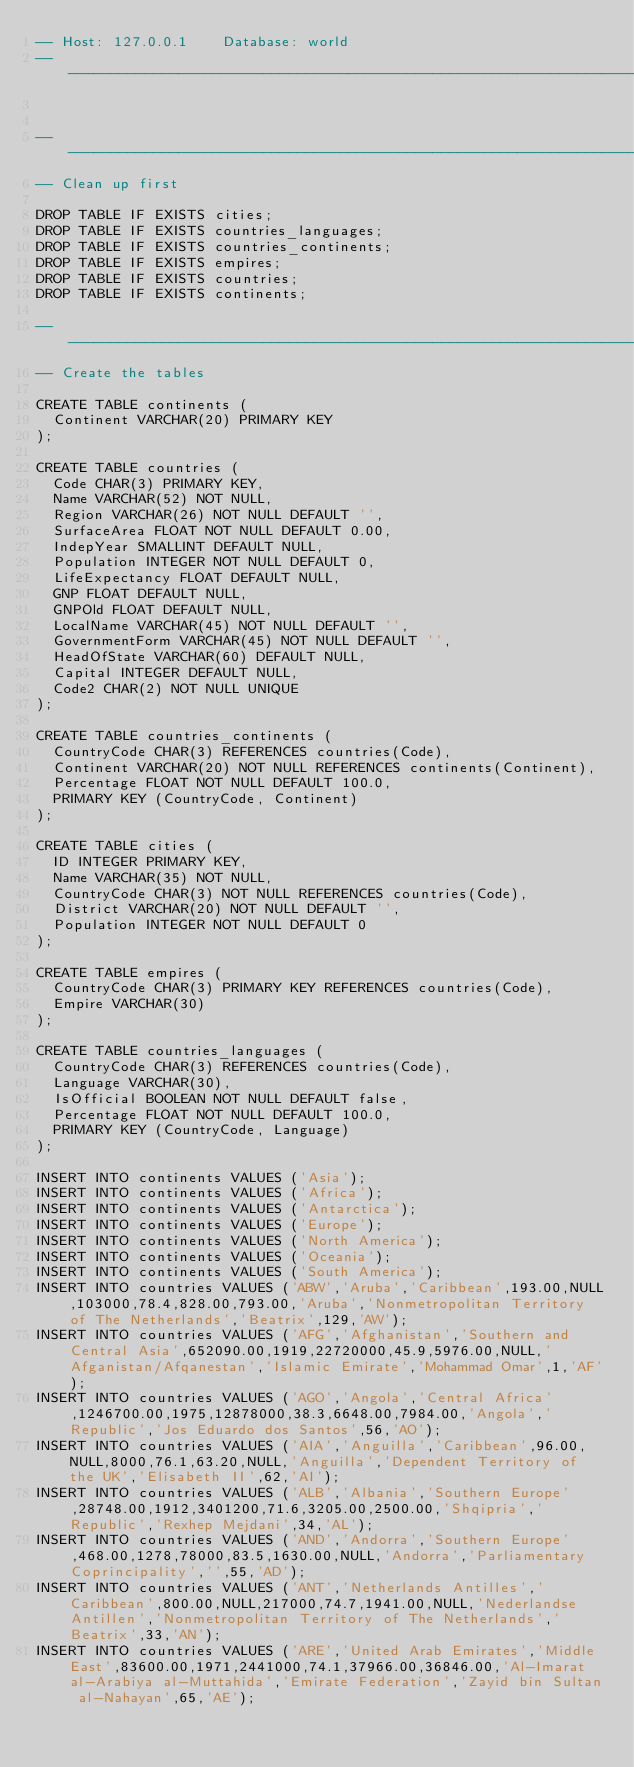<code> <loc_0><loc_0><loc_500><loc_500><_SQL_>-- Host: 127.0.0.1    Database: world
-- ----------------------------------------------------------------------------------------------------------------


-- ----------------------------------------------------------------------------------------------------------------
-- Clean up first

DROP TABLE IF EXISTS cities;
DROP TABLE IF EXISTS countries_languages;
DROP TABLE IF EXISTS countries_continents;
DROP TABLE IF EXISTS empires;
DROP TABLE IF EXISTS countries;
DROP TABLE IF EXISTS continents;

-- ----------------------------------------------------------------------------------------------------------------
-- Create the tables

CREATE TABLE continents (
  Continent VARCHAR(20) PRIMARY KEY
);

CREATE TABLE countries (
  Code CHAR(3) PRIMARY KEY,
  Name VARCHAR(52) NOT NULL,
  Region VARCHAR(26) NOT NULL DEFAULT '',
  SurfaceArea FLOAT NOT NULL DEFAULT 0.00,
  IndepYear SMALLINT DEFAULT NULL,
  Population INTEGER NOT NULL DEFAULT 0,
  LifeExpectancy FLOAT DEFAULT NULL,
  GNP FLOAT DEFAULT NULL,
  GNPOld FLOAT DEFAULT NULL,
  LocalName VARCHAR(45) NOT NULL DEFAULT '',
  GovernmentForm VARCHAR(45) NOT NULL DEFAULT '',
  HeadOfState VARCHAR(60) DEFAULT NULL,
  Capital INTEGER DEFAULT NULL,
  Code2 CHAR(2) NOT NULL UNIQUE
);

CREATE TABLE countries_continents (
  CountryCode CHAR(3) REFERENCES countries(Code),
  Continent VARCHAR(20) NOT NULL REFERENCES continents(Continent),
  Percentage FLOAT NOT NULL DEFAULT 100.0,
  PRIMARY KEY (CountryCode, Continent)
);

CREATE TABLE cities (
  ID INTEGER PRIMARY KEY,
  Name VARCHAR(35) NOT NULL,
  CountryCode CHAR(3) NOT NULL REFERENCES countries(Code),
  District VARCHAR(20) NOT NULL DEFAULT '',
  Population INTEGER NOT NULL DEFAULT 0
);

CREATE TABLE empires (
  CountryCode CHAR(3) PRIMARY KEY REFERENCES countries(Code),
  Empire VARCHAR(30)
);

CREATE TABLE countries_languages (
  CountryCode CHAR(3) REFERENCES countries(Code),
  Language VARCHAR(30),
  IsOfficial BOOLEAN NOT NULL DEFAULT false,
  Percentage FLOAT NOT NULL DEFAULT 100.0,
  PRIMARY KEY (CountryCode, Language)
);

INSERT INTO continents VALUES ('Asia');
INSERT INTO continents VALUES ('Africa');
INSERT INTO continents VALUES ('Antarctica');
INSERT INTO continents VALUES ('Europe');
INSERT INTO continents VALUES ('North America');
INSERT INTO continents VALUES ('Oceania');
INSERT INTO continents VALUES ('South America');
INSERT INTO countries VALUES ('ABW','Aruba','Caribbean',193.00,NULL,103000,78.4,828.00,793.00,'Aruba','Nonmetropolitan Territory of The Netherlands','Beatrix',129,'AW');
INSERT INTO countries VALUES ('AFG','Afghanistan','Southern and Central Asia',652090.00,1919,22720000,45.9,5976.00,NULL,'Afganistan/Afqanestan','Islamic Emirate','Mohammad Omar',1,'AF');
INSERT INTO countries VALUES ('AGO','Angola','Central Africa',1246700.00,1975,12878000,38.3,6648.00,7984.00,'Angola','Republic','Jos Eduardo dos Santos',56,'AO');
INSERT INTO countries VALUES ('AIA','Anguilla','Caribbean',96.00,NULL,8000,76.1,63.20,NULL,'Anguilla','Dependent Territory of the UK','Elisabeth II',62,'AI');
INSERT INTO countries VALUES ('ALB','Albania','Southern Europe',28748.00,1912,3401200,71.6,3205.00,2500.00,'Shqipria','Republic','Rexhep Mejdani',34,'AL');
INSERT INTO countries VALUES ('AND','Andorra','Southern Europe',468.00,1278,78000,83.5,1630.00,NULL,'Andorra','Parliamentary Coprincipality','',55,'AD');
INSERT INTO countries VALUES ('ANT','Netherlands Antilles','Caribbean',800.00,NULL,217000,74.7,1941.00,NULL,'Nederlandse Antillen','Nonmetropolitan Territory of The Netherlands','Beatrix',33,'AN');
INSERT INTO countries VALUES ('ARE','United Arab Emirates','Middle East',83600.00,1971,2441000,74.1,37966.00,36846.00,'Al-Imarat al-Arabiya al-Muttahida','Emirate Federation','Zayid bin Sultan al-Nahayan',65,'AE');</code> 